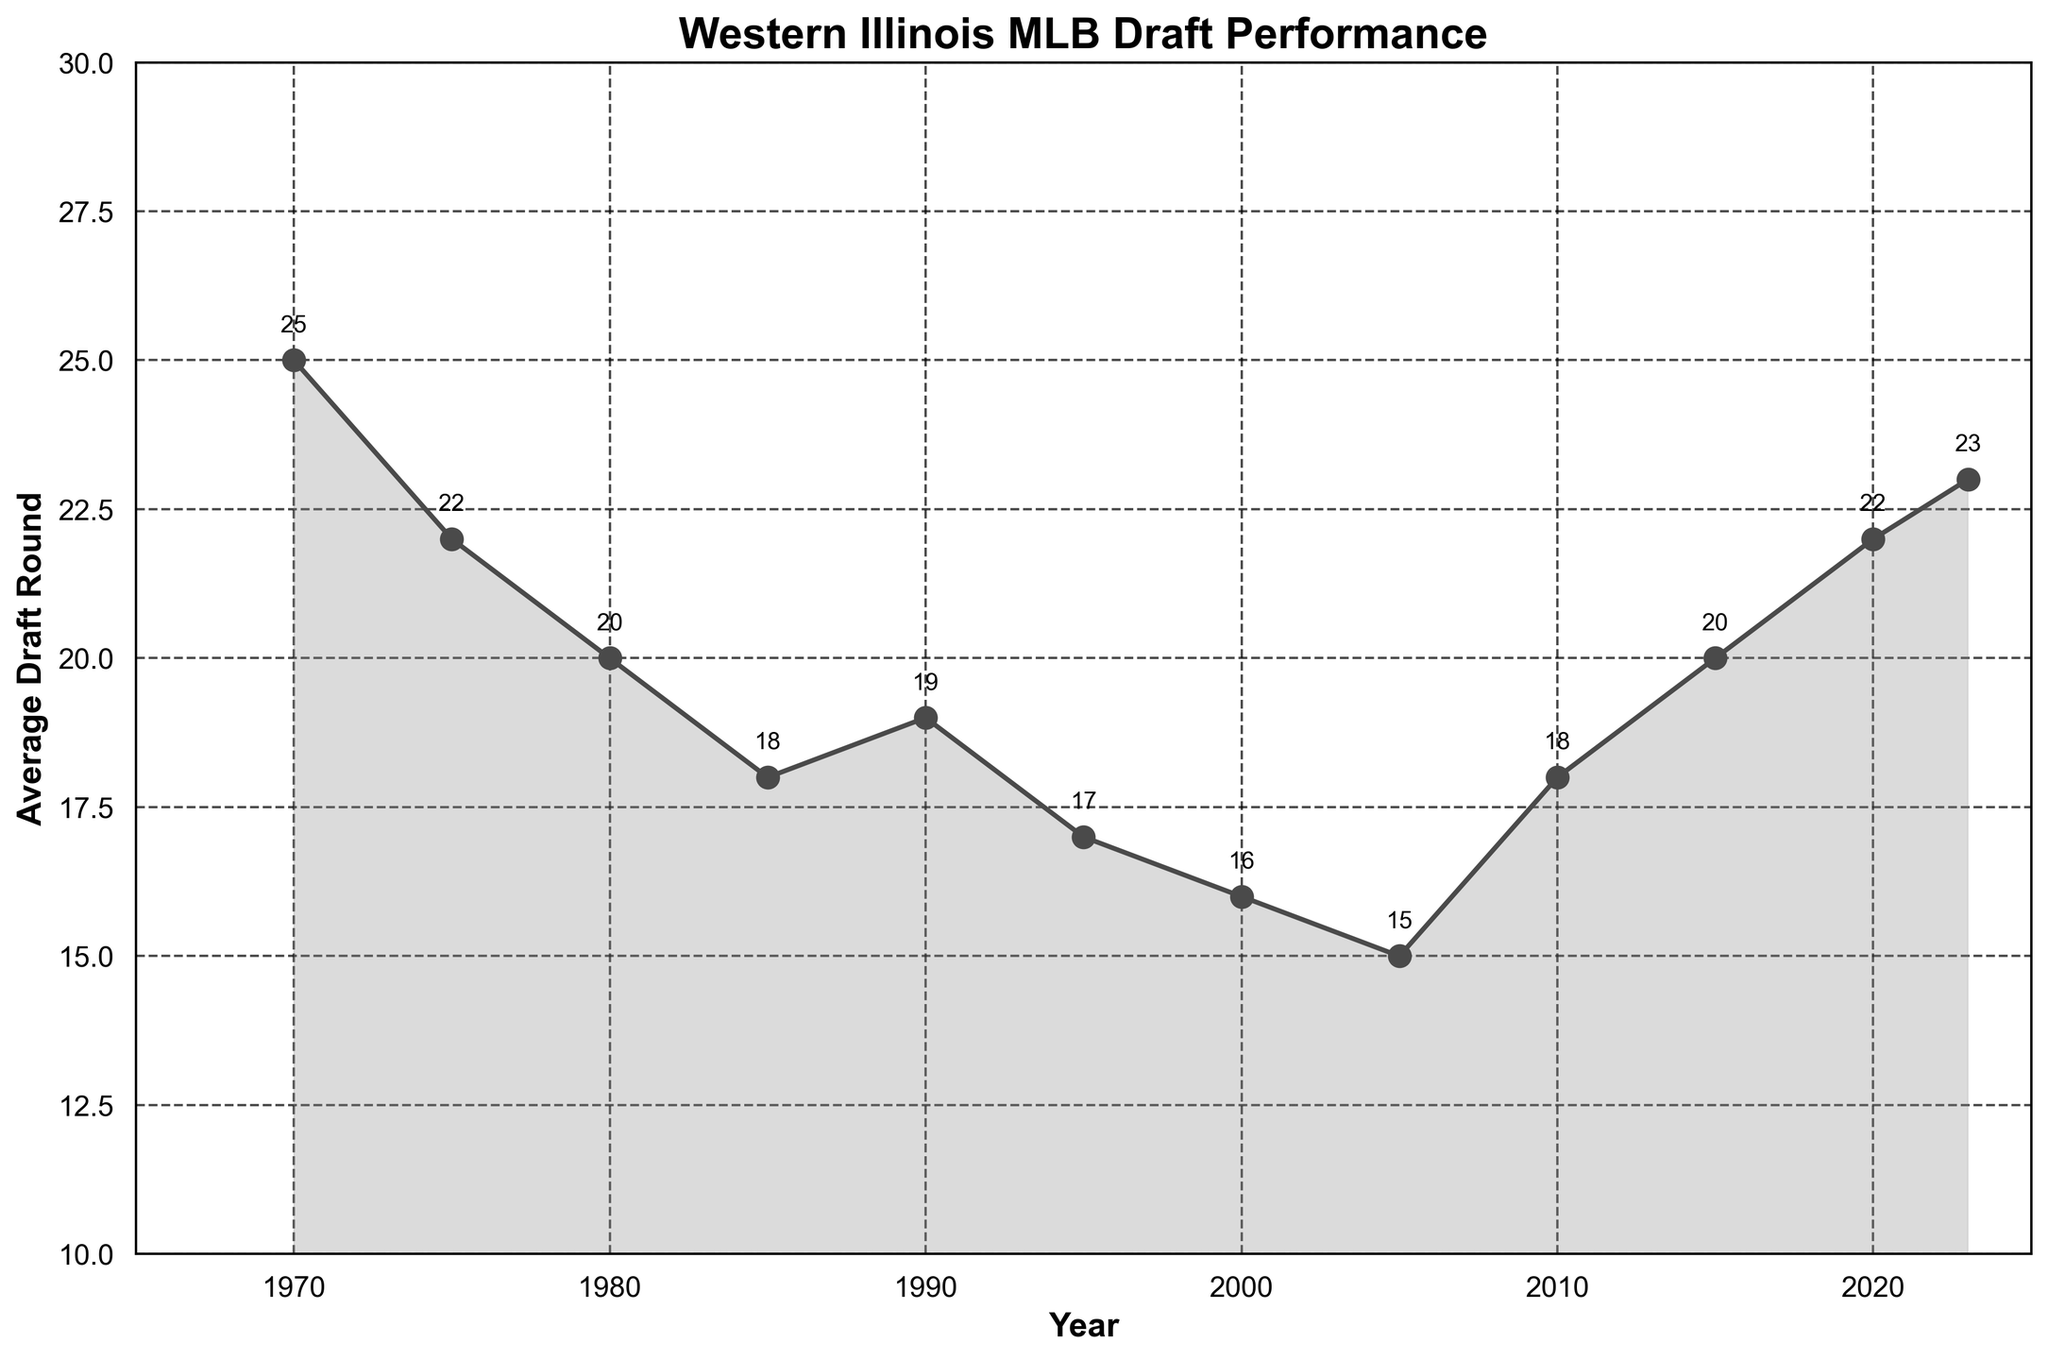what is the average draft round for Western Illinois players in 2000? Look at the point on the line chart corresponding to the year 2000 on the x-axis. The y-axis value indicates the average draft round.
Answer: 16 In which year did Western Illinois baseball players have the highest average draft round? Locate the highest point on the line chart along the y-axis. Check the corresponding year on the x-axis.
Answer: 1970 Compare the average draft round in 1985 and 2020. Which year has a lower average draft round? Find the points for 1985 and 2020 on the x-axis and compare their y-axis values. The lower value represents a lower average draft round.
Answer: 1985 Between which years did the average draft round experience the most significant increase? Identify where the line rises the steepest by looking at the differences in y-axis values between consecutive years. The largest difference indicates the most significant increase.
Answer: 2005 to 2010 How many years had an average draft round below 20? Count the number of points on the line chart that fall below the y-axis value of 20.
Answer: 6 What is the average of the average draft rounds for the years 1990, 1995, and 2000? Extract the average draft rounds for the years 1990 (19), 1995 (17), and 2000 (16), then compute the mean: (19 + 17 + 16) / 3 = 17.33
Answer: 17.33 From 1970 to 2023, how many times did the average draft round increase consecutively for at least two points on the graph? Look for consecutive rising points in the line chart and count such appearances: 1990 to 1995, 2005 to 2010, 2010 to 2015, and 2015 to 2020, 2020 to 2023
Answer: 5 